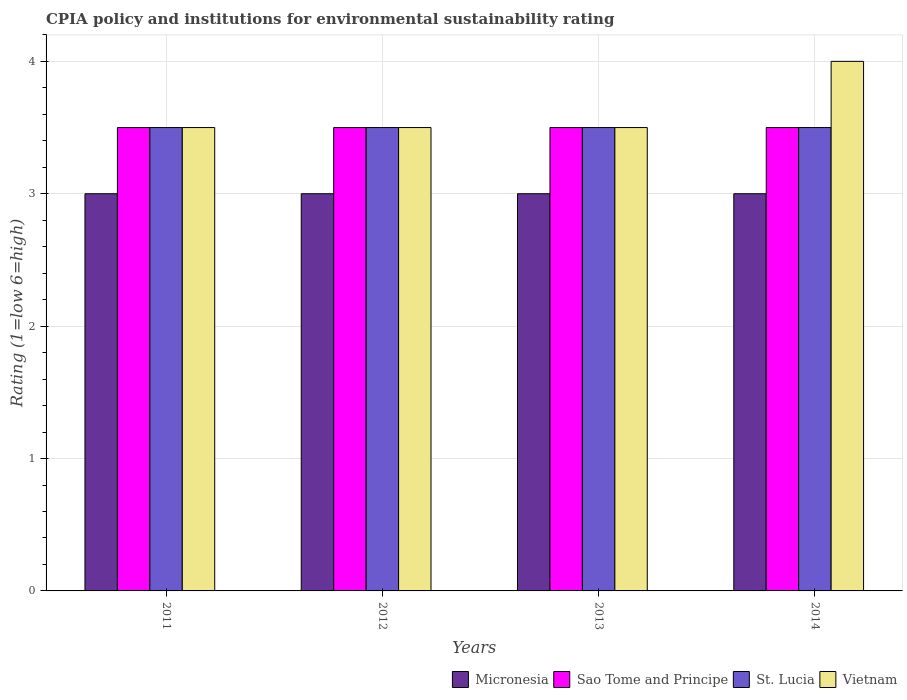Are the number of bars on each tick of the X-axis equal?
Ensure brevity in your answer.  Yes. How many bars are there on the 2nd tick from the left?
Give a very brief answer. 4. What is the CPIA rating in St. Lucia in 2011?
Offer a very short reply. 3.5. Across all years, what is the maximum CPIA rating in Vietnam?
Keep it short and to the point. 4. In which year was the CPIA rating in Micronesia maximum?
Provide a succinct answer. 2011. In which year was the CPIA rating in St. Lucia minimum?
Offer a terse response. 2011. What is the difference between the CPIA rating in St. Lucia in 2011 and the CPIA rating in Sao Tome and Principe in 2013?
Give a very brief answer. 0. What is the average CPIA rating in St. Lucia per year?
Offer a terse response. 3.5. In the year 2012, what is the difference between the CPIA rating in Micronesia and CPIA rating in St. Lucia?
Provide a succinct answer. -0.5. In how many years, is the CPIA rating in Sao Tome and Principe greater than 3.4?
Your response must be concise. 4. What is the ratio of the CPIA rating in Vietnam in 2013 to that in 2014?
Your response must be concise. 0.88. Is the CPIA rating in Micronesia in 2011 less than that in 2012?
Your response must be concise. No. In how many years, is the CPIA rating in Micronesia greater than the average CPIA rating in Micronesia taken over all years?
Make the answer very short. 0. Is the sum of the CPIA rating in Micronesia in 2012 and 2013 greater than the maximum CPIA rating in St. Lucia across all years?
Make the answer very short. Yes. What does the 3rd bar from the left in 2011 represents?
Your answer should be very brief. St. Lucia. What does the 3rd bar from the right in 2011 represents?
Provide a short and direct response. Sao Tome and Principe. How many bars are there?
Your answer should be very brief. 16. Are all the bars in the graph horizontal?
Give a very brief answer. No. What is the difference between two consecutive major ticks on the Y-axis?
Give a very brief answer. 1. Are the values on the major ticks of Y-axis written in scientific E-notation?
Your response must be concise. No. Where does the legend appear in the graph?
Provide a succinct answer. Bottom right. How many legend labels are there?
Ensure brevity in your answer.  4. How are the legend labels stacked?
Offer a terse response. Horizontal. What is the title of the graph?
Your response must be concise. CPIA policy and institutions for environmental sustainability rating. Does "Curacao" appear as one of the legend labels in the graph?
Provide a short and direct response. No. What is the label or title of the X-axis?
Your response must be concise. Years. What is the Rating (1=low 6=high) in Micronesia in 2012?
Provide a short and direct response. 3. What is the Rating (1=low 6=high) of Sao Tome and Principe in 2012?
Keep it short and to the point. 3.5. What is the Rating (1=low 6=high) in St. Lucia in 2013?
Your response must be concise. 3.5. What is the Rating (1=low 6=high) in Vietnam in 2013?
Provide a short and direct response. 3.5. What is the Rating (1=low 6=high) in Sao Tome and Principe in 2014?
Provide a succinct answer. 3.5. Across all years, what is the maximum Rating (1=low 6=high) in Micronesia?
Provide a succinct answer. 3. Across all years, what is the maximum Rating (1=low 6=high) in Sao Tome and Principe?
Ensure brevity in your answer.  3.5. Across all years, what is the minimum Rating (1=low 6=high) in Micronesia?
Provide a short and direct response. 3. What is the total Rating (1=low 6=high) in Micronesia in the graph?
Make the answer very short. 12. What is the total Rating (1=low 6=high) in Sao Tome and Principe in the graph?
Make the answer very short. 14. What is the total Rating (1=low 6=high) of St. Lucia in the graph?
Make the answer very short. 14. What is the difference between the Rating (1=low 6=high) of Sao Tome and Principe in 2011 and that in 2012?
Offer a very short reply. 0. What is the difference between the Rating (1=low 6=high) in St. Lucia in 2011 and that in 2012?
Make the answer very short. 0. What is the difference between the Rating (1=low 6=high) of Vietnam in 2011 and that in 2012?
Give a very brief answer. 0. What is the difference between the Rating (1=low 6=high) of Vietnam in 2011 and that in 2013?
Your answer should be very brief. 0. What is the difference between the Rating (1=low 6=high) in Micronesia in 2011 and that in 2014?
Give a very brief answer. 0. What is the difference between the Rating (1=low 6=high) in Sao Tome and Principe in 2012 and that in 2013?
Your response must be concise. 0. What is the difference between the Rating (1=low 6=high) of St. Lucia in 2012 and that in 2013?
Ensure brevity in your answer.  0. What is the difference between the Rating (1=low 6=high) of Vietnam in 2012 and that in 2014?
Your response must be concise. -0.5. What is the difference between the Rating (1=low 6=high) in Micronesia in 2013 and that in 2014?
Keep it short and to the point. 0. What is the difference between the Rating (1=low 6=high) of Sao Tome and Principe in 2013 and that in 2014?
Your response must be concise. 0. What is the difference between the Rating (1=low 6=high) of St. Lucia in 2013 and that in 2014?
Provide a short and direct response. 0. What is the difference between the Rating (1=low 6=high) of Vietnam in 2013 and that in 2014?
Your answer should be very brief. -0.5. What is the difference between the Rating (1=low 6=high) of Micronesia in 2011 and the Rating (1=low 6=high) of Vietnam in 2012?
Give a very brief answer. -0.5. What is the difference between the Rating (1=low 6=high) in Sao Tome and Principe in 2011 and the Rating (1=low 6=high) in Vietnam in 2012?
Provide a short and direct response. 0. What is the difference between the Rating (1=low 6=high) in St. Lucia in 2011 and the Rating (1=low 6=high) in Vietnam in 2012?
Provide a short and direct response. 0. What is the difference between the Rating (1=low 6=high) in Micronesia in 2011 and the Rating (1=low 6=high) in Sao Tome and Principe in 2013?
Offer a very short reply. -0.5. What is the difference between the Rating (1=low 6=high) of Micronesia in 2011 and the Rating (1=low 6=high) of St. Lucia in 2013?
Give a very brief answer. -0.5. What is the difference between the Rating (1=low 6=high) in Micronesia in 2011 and the Rating (1=low 6=high) in Vietnam in 2013?
Give a very brief answer. -0.5. What is the difference between the Rating (1=low 6=high) of Sao Tome and Principe in 2011 and the Rating (1=low 6=high) of Vietnam in 2013?
Provide a succinct answer. 0. What is the difference between the Rating (1=low 6=high) of Sao Tome and Principe in 2011 and the Rating (1=low 6=high) of St. Lucia in 2014?
Your answer should be compact. 0. What is the difference between the Rating (1=low 6=high) of Sao Tome and Principe in 2011 and the Rating (1=low 6=high) of Vietnam in 2014?
Give a very brief answer. -0.5. What is the difference between the Rating (1=low 6=high) of St. Lucia in 2011 and the Rating (1=low 6=high) of Vietnam in 2014?
Ensure brevity in your answer.  -0.5. What is the difference between the Rating (1=low 6=high) in Micronesia in 2012 and the Rating (1=low 6=high) in Sao Tome and Principe in 2013?
Offer a very short reply. -0.5. What is the difference between the Rating (1=low 6=high) in Micronesia in 2012 and the Rating (1=low 6=high) in Vietnam in 2013?
Make the answer very short. -0.5. What is the difference between the Rating (1=low 6=high) of Sao Tome and Principe in 2012 and the Rating (1=low 6=high) of Vietnam in 2013?
Make the answer very short. 0. What is the difference between the Rating (1=low 6=high) in Sao Tome and Principe in 2012 and the Rating (1=low 6=high) in Vietnam in 2014?
Give a very brief answer. -0.5. What is the difference between the Rating (1=low 6=high) in St. Lucia in 2012 and the Rating (1=low 6=high) in Vietnam in 2014?
Give a very brief answer. -0.5. What is the difference between the Rating (1=low 6=high) of Micronesia in 2013 and the Rating (1=low 6=high) of Sao Tome and Principe in 2014?
Your response must be concise. -0.5. What is the difference between the Rating (1=low 6=high) in Micronesia in 2013 and the Rating (1=low 6=high) in St. Lucia in 2014?
Provide a short and direct response. -0.5. What is the difference between the Rating (1=low 6=high) in Micronesia in 2013 and the Rating (1=low 6=high) in Vietnam in 2014?
Keep it short and to the point. -1. What is the difference between the Rating (1=low 6=high) in Sao Tome and Principe in 2013 and the Rating (1=low 6=high) in Vietnam in 2014?
Your answer should be compact. -0.5. What is the average Rating (1=low 6=high) of Micronesia per year?
Your answer should be very brief. 3. What is the average Rating (1=low 6=high) in St. Lucia per year?
Give a very brief answer. 3.5. What is the average Rating (1=low 6=high) of Vietnam per year?
Your response must be concise. 3.62. In the year 2011, what is the difference between the Rating (1=low 6=high) in Micronesia and Rating (1=low 6=high) in Vietnam?
Your response must be concise. -0.5. In the year 2011, what is the difference between the Rating (1=low 6=high) in St. Lucia and Rating (1=low 6=high) in Vietnam?
Provide a succinct answer. 0. In the year 2012, what is the difference between the Rating (1=low 6=high) of Micronesia and Rating (1=low 6=high) of Sao Tome and Principe?
Ensure brevity in your answer.  -0.5. In the year 2012, what is the difference between the Rating (1=low 6=high) in Micronesia and Rating (1=low 6=high) in St. Lucia?
Provide a succinct answer. -0.5. In the year 2012, what is the difference between the Rating (1=low 6=high) of Micronesia and Rating (1=low 6=high) of Vietnam?
Make the answer very short. -0.5. In the year 2012, what is the difference between the Rating (1=low 6=high) in Sao Tome and Principe and Rating (1=low 6=high) in St. Lucia?
Give a very brief answer. 0. In the year 2013, what is the difference between the Rating (1=low 6=high) of Micronesia and Rating (1=low 6=high) of Sao Tome and Principe?
Your answer should be very brief. -0.5. In the year 2013, what is the difference between the Rating (1=low 6=high) of Micronesia and Rating (1=low 6=high) of Vietnam?
Offer a terse response. -0.5. In the year 2013, what is the difference between the Rating (1=low 6=high) of Sao Tome and Principe and Rating (1=low 6=high) of Vietnam?
Your answer should be very brief. 0. In the year 2013, what is the difference between the Rating (1=low 6=high) in St. Lucia and Rating (1=low 6=high) in Vietnam?
Keep it short and to the point. 0. In the year 2014, what is the difference between the Rating (1=low 6=high) in Micronesia and Rating (1=low 6=high) in Vietnam?
Give a very brief answer. -1. In the year 2014, what is the difference between the Rating (1=low 6=high) of Sao Tome and Principe and Rating (1=low 6=high) of St. Lucia?
Provide a succinct answer. 0. What is the ratio of the Rating (1=low 6=high) of Micronesia in 2011 to that in 2012?
Provide a succinct answer. 1. What is the ratio of the Rating (1=low 6=high) of Sao Tome and Principe in 2011 to that in 2012?
Your answer should be compact. 1. What is the ratio of the Rating (1=low 6=high) in St. Lucia in 2011 to that in 2012?
Offer a very short reply. 1. What is the ratio of the Rating (1=low 6=high) in Micronesia in 2011 to that in 2013?
Your response must be concise. 1. What is the ratio of the Rating (1=low 6=high) in St. Lucia in 2011 to that in 2013?
Your response must be concise. 1. What is the ratio of the Rating (1=low 6=high) of Micronesia in 2011 to that in 2014?
Offer a very short reply. 1. What is the ratio of the Rating (1=low 6=high) in Sao Tome and Principe in 2011 to that in 2014?
Make the answer very short. 1. What is the ratio of the Rating (1=low 6=high) in St. Lucia in 2012 to that in 2013?
Give a very brief answer. 1. What is the ratio of the Rating (1=low 6=high) in Vietnam in 2012 to that in 2013?
Offer a very short reply. 1. What is the ratio of the Rating (1=low 6=high) in Micronesia in 2012 to that in 2014?
Offer a very short reply. 1. What is the ratio of the Rating (1=low 6=high) of Sao Tome and Principe in 2012 to that in 2014?
Make the answer very short. 1. What is the ratio of the Rating (1=low 6=high) in St. Lucia in 2012 to that in 2014?
Offer a very short reply. 1. What is the ratio of the Rating (1=low 6=high) of Vietnam in 2012 to that in 2014?
Offer a very short reply. 0.88. What is the ratio of the Rating (1=low 6=high) of Micronesia in 2013 to that in 2014?
Your answer should be compact. 1. What is the ratio of the Rating (1=low 6=high) in St. Lucia in 2013 to that in 2014?
Ensure brevity in your answer.  1. What is the ratio of the Rating (1=low 6=high) in Vietnam in 2013 to that in 2014?
Give a very brief answer. 0.88. What is the difference between the highest and the second highest Rating (1=low 6=high) of Vietnam?
Ensure brevity in your answer.  0.5. What is the difference between the highest and the lowest Rating (1=low 6=high) in Micronesia?
Ensure brevity in your answer.  0. 